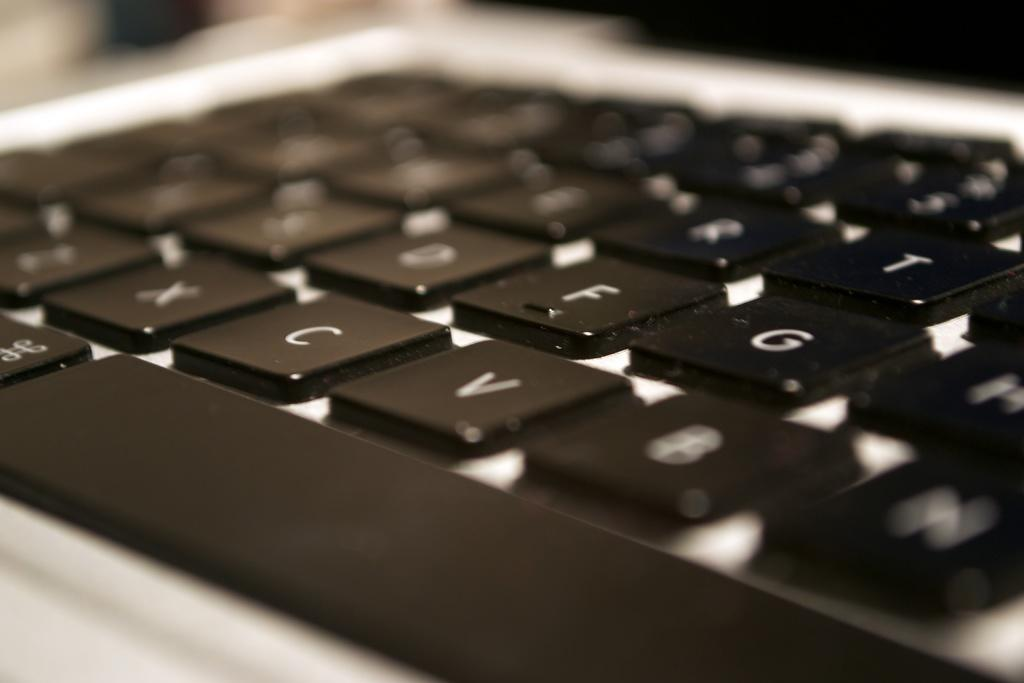<image>
Give a short and clear explanation of the subsequent image. The black keys of a keyboard of which the letter N is at the bottom right. 